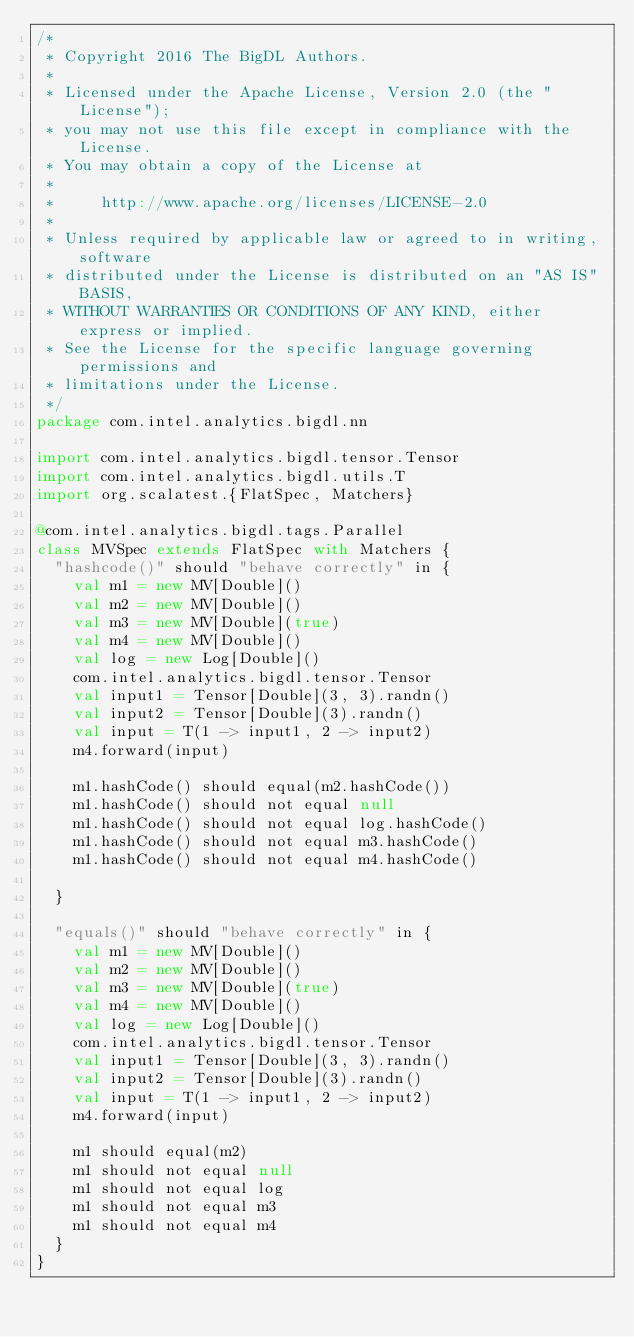<code> <loc_0><loc_0><loc_500><loc_500><_Scala_>/*
 * Copyright 2016 The BigDL Authors.
 *
 * Licensed under the Apache License, Version 2.0 (the "License");
 * you may not use this file except in compliance with the License.
 * You may obtain a copy of the License at
 *
 *     http://www.apache.org/licenses/LICENSE-2.0
 *
 * Unless required by applicable law or agreed to in writing, software
 * distributed under the License is distributed on an "AS IS" BASIS,
 * WITHOUT WARRANTIES OR CONDITIONS OF ANY KIND, either express or implied.
 * See the License for the specific language governing permissions and
 * limitations under the License.
 */
package com.intel.analytics.bigdl.nn

import com.intel.analytics.bigdl.tensor.Tensor
import com.intel.analytics.bigdl.utils.T
import org.scalatest.{FlatSpec, Matchers}

@com.intel.analytics.bigdl.tags.Parallel
class MVSpec extends FlatSpec with Matchers {
  "hashcode()" should "behave correctly" in {
    val m1 = new MV[Double]()
    val m2 = new MV[Double]()
    val m3 = new MV[Double](true)
    val m4 = new MV[Double]()
    val log = new Log[Double]()
    com.intel.analytics.bigdl.tensor.Tensor
    val input1 = Tensor[Double](3, 3).randn()
    val input2 = Tensor[Double](3).randn()
    val input = T(1 -> input1, 2 -> input2)
    m4.forward(input)

    m1.hashCode() should equal(m2.hashCode())
    m1.hashCode() should not equal null
    m1.hashCode() should not equal log.hashCode()
    m1.hashCode() should not equal m3.hashCode()
    m1.hashCode() should not equal m4.hashCode()

  }

  "equals()" should "behave correctly" in {
    val m1 = new MV[Double]()
    val m2 = new MV[Double]()
    val m3 = new MV[Double](true)
    val m4 = new MV[Double]()
    val log = new Log[Double]()
    com.intel.analytics.bigdl.tensor.Tensor
    val input1 = Tensor[Double](3, 3).randn()
    val input2 = Tensor[Double](3).randn()
    val input = T(1 -> input1, 2 -> input2)
    m4.forward(input)

    m1 should equal(m2)
    m1 should not equal null
    m1 should not equal log
    m1 should not equal m3
    m1 should not equal m4
  }
}
</code> 